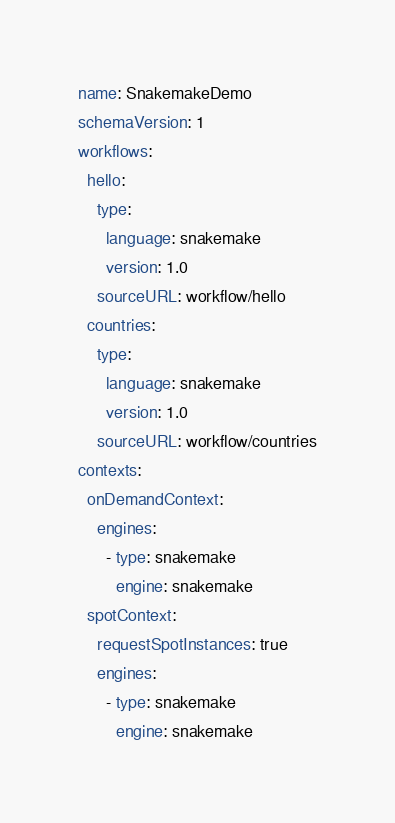<code> <loc_0><loc_0><loc_500><loc_500><_YAML_>name: SnakemakeDemo
schemaVersion: 1
workflows:
  hello:
    type:
      language: snakemake
      version: 1.0
    sourceURL: workflow/hello
  countries:
    type:
      language: snakemake
      version: 1.0
    sourceURL: workflow/countries
contexts:
  onDemandContext:
    engines:
      - type: snakemake
        engine: snakemake
  spotContext:
    requestSpotInstances: true
    engines:
      - type: snakemake
        engine: snakemake</code> 